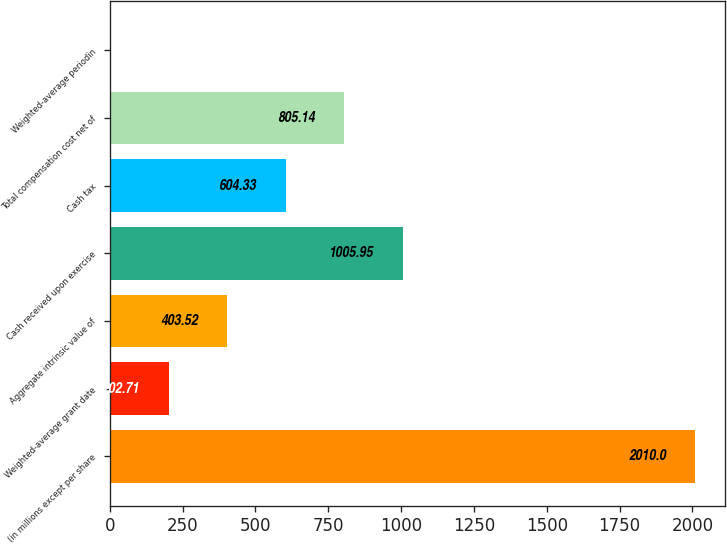Convert chart to OTSL. <chart><loc_0><loc_0><loc_500><loc_500><bar_chart><fcel>(in millions except per share<fcel>Weighted-average grant date<fcel>Aggregate intrinsic value of<fcel>Cash received upon exercise<fcel>Cash tax<fcel>Total compensation cost net of<fcel>Weighted-average periodin<nl><fcel>2010<fcel>202.71<fcel>403.52<fcel>1005.95<fcel>604.33<fcel>805.14<fcel>1.9<nl></chart> 